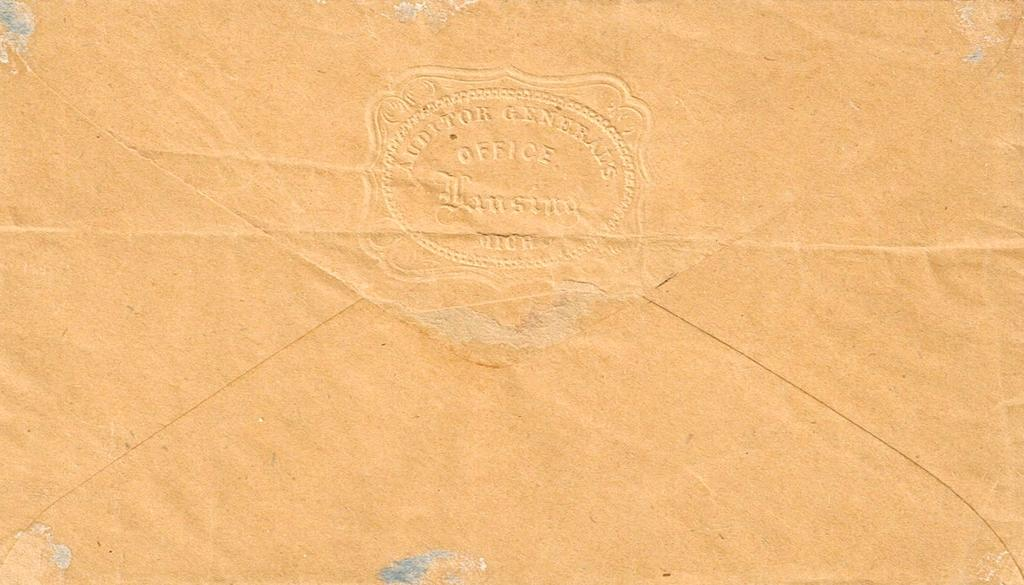<image>
Render a clear and concise summary of the photo. AN ENVELOP WITH THE WRITING "AUDITOR GENERAL OFFICE" ON IT. 